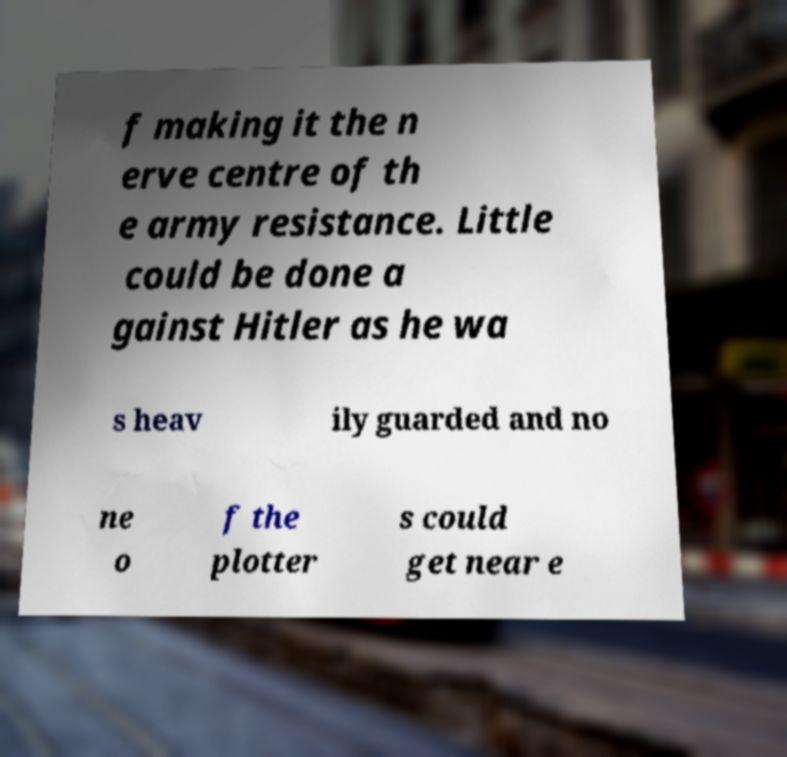Could you extract and type out the text from this image? f making it the n erve centre of th e army resistance. Little could be done a gainst Hitler as he wa s heav ily guarded and no ne o f the plotter s could get near e 